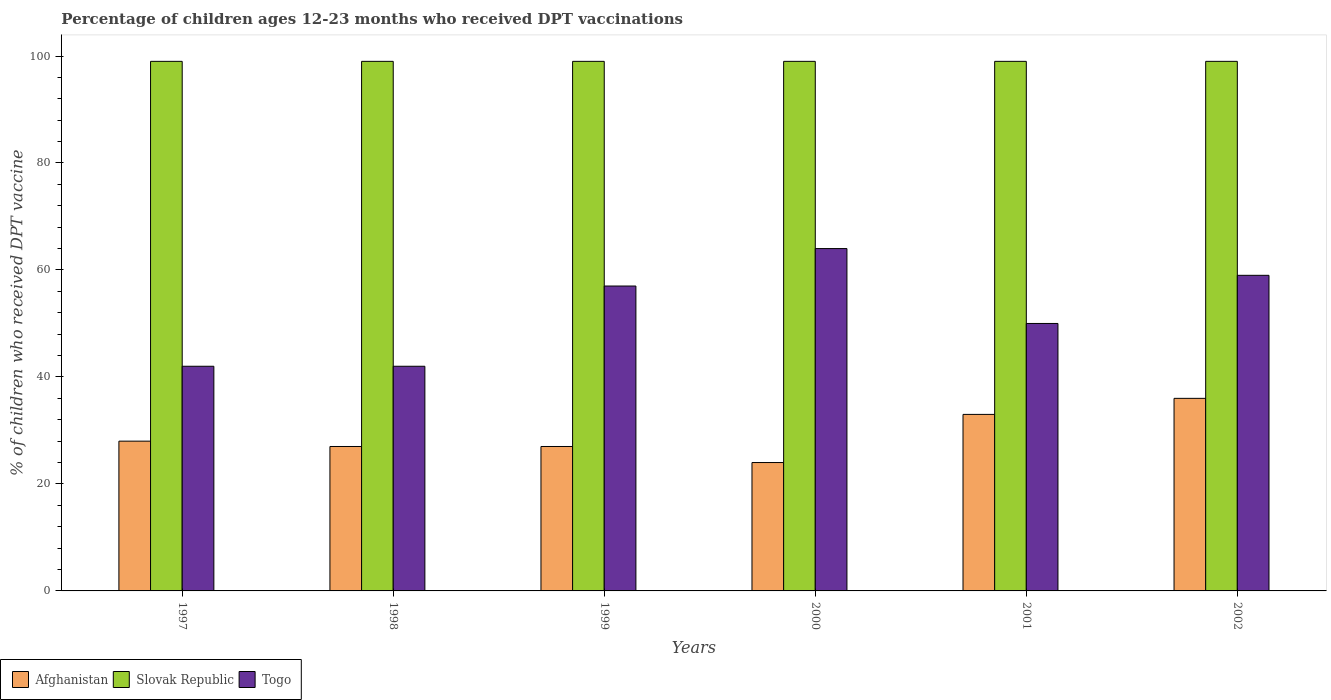How many different coloured bars are there?
Provide a short and direct response. 3. How many groups of bars are there?
Keep it short and to the point. 6. Are the number of bars per tick equal to the number of legend labels?
Your response must be concise. Yes. Are the number of bars on each tick of the X-axis equal?
Make the answer very short. Yes. How many bars are there on the 2nd tick from the left?
Offer a terse response. 3. How many bars are there on the 3rd tick from the right?
Your answer should be compact. 3. In how many cases, is the number of bars for a given year not equal to the number of legend labels?
Provide a succinct answer. 0. What is the percentage of children who received DPT vaccination in Afghanistan in 1998?
Ensure brevity in your answer.  27. Across all years, what is the maximum percentage of children who received DPT vaccination in Afghanistan?
Offer a very short reply. 36. In which year was the percentage of children who received DPT vaccination in Togo minimum?
Offer a terse response. 1997. What is the total percentage of children who received DPT vaccination in Togo in the graph?
Offer a very short reply. 314. What is the difference between the percentage of children who received DPT vaccination in Afghanistan in 1998 and that in 2000?
Make the answer very short. 3. In the year 2000, what is the difference between the percentage of children who received DPT vaccination in Slovak Republic and percentage of children who received DPT vaccination in Afghanistan?
Make the answer very short. 75. In how many years, is the percentage of children who received DPT vaccination in Slovak Republic greater than 76 %?
Offer a terse response. 6. Is the percentage of children who received DPT vaccination in Afghanistan in 1998 less than that in 1999?
Provide a succinct answer. No. Is the difference between the percentage of children who received DPT vaccination in Slovak Republic in 1999 and 2002 greater than the difference between the percentage of children who received DPT vaccination in Afghanistan in 1999 and 2002?
Your response must be concise. Yes. What is the difference between the highest and the second highest percentage of children who received DPT vaccination in Togo?
Offer a terse response. 5. What is the difference between the highest and the lowest percentage of children who received DPT vaccination in Slovak Republic?
Make the answer very short. 0. What does the 1st bar from the left in 2000 represents?
Keep it short and to the point. Afghanistan. What does the 2nd bar from the right in 2001 represents?
Provide a short and direct response. Slovak Republic. How many legend labels are there?
Offer a very short reply. 3. What is the title of the graph?
Ensure brevity in your answer.  Percentage of children ages 12-23 months who received DPT vaccinations. What is the label or title of the X-axis?
Your answer should be compact. Years. What is the label or title of the Y-axis?
Keep it short and to the point. % of children who received DPT vaccine. What is the % of children who received DPT vaccine in Slovak Republic in 1997?
Offer a terse response. 99. What is the % of children who received DPT vaccine in Afghanistan in 1999?
Ensure brevity in your answer.  27. What is the % of children who received DPT vaccine in Slovak Republic in 1999?
Your answer should be compact. 99. What is the % of children who received DPT vaccine of Afghanistan in 2000?
Make the answer very short. 24. What is the % of children who received DPT vaccine in Slovak Republic in 2000?
Your response must be concise. 99. What is the % of children who received DPT vaccine in Togo in 2000?
Make the answer very short. 64. What is the % of children who received DPT vaccine in Slovak Republic in 2001?
Your response must be concise. 99. What is the % of children who received DPT vaccine in Togo in 2001?
Offer a terse response. 50. What is the % of children who received DPT vaccine in Afghanistan in 2002?
Provide a short and direct response. 36. What is the % of children who received DPT vaccine of Togo in 2002?
Keep it short and to the point. 59. Across all years, what is the maximum % of children who received DPT vaccine of Afghanistan?
Ensure brevity in your answer.  36. Across all years, what is the minimum % of children who received DPT vaccine in Slovak Republic?
Give a very brief answer. 99. Across all years, what is the minimum % of children who received DPT vaccine in Togo?
Ensure brevity in your answer.  42. What is the total % of children who received DPT vaccine in Afghanistan in the graph?
Offer a terse response. 175. What is the total % of children who received DPT vaccine in Slovak Republic in the graph?
Your response must be concise. 594. What is the total % of children who received DPT vaccine in Togo in the graph?
Keep it short and to the point. 314. What is the difference between the % of children who received DPT vaccine of Togo in 1997 and that in 1998?
Keep it short and to the point. 0. What is the difference between the % of children who received DPT vaccine in Togo in 1997 and that in 1999?
Ensure brevity in your answer.  -15. What is the difference between the % of children who received DPT vaccine of Togo in 1997 and that in 2001?
Make the answer very short. -8. What is the difference between the % of children who received DPT vaccine of Afghanistan in 1997 and that in 2002?
Make the answer very short. -8. What is the difference between the % of children who received DPT vaccine of Slovak Republic in 1998 and that in 1999?
Your answer should be very brief. 0. What is the difference between the % of children who received DPT vaccine in Afghanistan in 1998 and that in 2000?
Your answer should be very brief. 3. What is the difference between the % of children who received DPT vaccine in Slovak Republic in 1998 and that in 2000?
Make the answer very short. 0. What is the difference between the % of children who received DPT vaccine of Togo in 1998 and that in 2000?
Make the answer very short. -22. What is the difference between the % of children who received DPT vaccine of Afghanistan in 1998 and that in 2001?
Ensure brevity in your answer.  -6. What is the difference between the % of children who received DPT vaccine in Slovak Republic in 1998 and that in 2001?
Your response must be concise. 0. What is the difference between the % of children who received DPT vaccine in Slovak Republic in 1998 and that in 2002?
Keep it short and to the point. 0. What is the difference between the % of children who received DPT vaccine of Afghanistan in 1999 and that in 2000?
Ensure brevity in your answer.  3. What is the difference between the % of children who received DPT vaccine in Slovak Republic in 1999 and that in 2000?
Your answer should be very brief. 0. What is the difference between the % of children who received DPT vaccine of Afghanistan in 1999 and that in 2002?
Your response must be concise. -9. What is the difference between the % of children who received DPT vaccine of Afghanistan in 2000 and that in 2001?
Offer a very short reply. -9. What is the difference between the % of children who received DPT vaccine in Afghanistan in 2000 and that in 2002?
Your answer should be compact. -12. What is the difference between the % of children who received DPT vaccine in Afghanistan in 1997 and the % of children who received DPT vaccine in Slovak Republic in 1998?
Offer a very short reply. -71. What is the difference between the % of children who received DPT vaccine of Afghanistan in 1997 and the % of children who received DPT vaccine of Togo in 1998?
Your answer should be very brief. -14. What is the difference between the % of children who received DPT vaccine in Slovak Republic in 1997 and the % of children who received DPT vaccine in Togo in 1998?
Provide a succinct answer. 57. What is the difference between the % of children who received DPT vaccine of Afghanistan in 1997 and the % of children who received DPT vaccine of Slovak Republic in 1999?
Your answer should be very brief. -71. What is the difference between the % of children who received DPT vaccine in Slovak Republic in 1997 and the % of children who received DPT vaccine in Togo in 1999?
Keep it short and to the point. 42. What is the difference between the % of children who received DPT vaccine in Afghanistan in 1997 and the % of children who received DPT vaccine in Slovak Republic in 2000?
Make the answer very short. -71. What is the difference between the % of children who received DPT vaccine in Afghanistan in 1997 and the % of children who received DPT vaccine in Togo in 2000?
Offer a terse response. -36. What is the difference between the % of children who received DPT vaccine of Afghanistan in 1997 and the % of children who received DPT vaccine of Slovak Republic in 2001?
Keep it short and to the point. -71. What is the difference between the % of children who received DPT vaccine of Afghanistan in 1997 and the % of children who received DPT vaccine of Togo in 2001?
Provide a short and direct response. -22. What is the difference between the % of children who received DPT vaccine in Afghanistan in 1997 and the % of children who received DPT vaccine in Slovak Republic in 2002?
Give a very brief answer. -71. What is the difference between the % of children who received DPT vaccine of Afghanistan in 1997 and the % of children who received DPT vaccine of Togo in 2002?
Give a very brief answer. -31. What is the difference between the % of children who received DPT vaccine of Afghanistan in 1998 and the % of children who received DPT vaccine of Slovak Republic in 1999?
Your answer should be compact. -72. What is the difference between the % of children who received DPT vaccine of Afghanistan in 1998 and the % of children who received DPT vaccine of Slovak Republic in 2000?
Make the answer very short. -72. What is the difference between the % of children who received DPT vaccine of Afghanistan in 1998 and the % of children who received DPT vaccine of Togo in 2000?
Keep it short and to the point. -37. What is the difference between the % of children who received DPT vaccine in Slovak Republic in 1998 and the % of children who received DPT vaccine in Togo in 2000?
Your response must be concise. 35. What is the difference between the % of children who received DPT vaccine of Afghanistan in 1998 and the % of children who received DPT vaccine of Slovak Republic in 2001?
Your answer should be very brief. -72. What is the difference between the % of children who received DPT vaccine in Slovak Republic in 1998 and the % of children who received DPT vaccine in Togo in 2001?
Provide a short and direct response. 49. What is the difference between the % of children who received DPT vaccine of Afghanistan in 1998 and the % of children who received DPT vaccine of Slovak Republic in 2002?
Your response must be concise. -72. What is the difference between the % of children who received DPT vaccine of Afghanistan in 1998 and the % of children who received DPT vaccine of Togo in 2002?
Keep it short and to the point. -32. What is the difference between the % of children who received DPT vaccine of Afghanistan in 1999 and the % of children who received DPT vaccine of Slovak Republic in 2000?
Keep it short and to the point. -72. What is the difference between the % of children who received DPT vaccine in Afghanistan in 1999 and the % of children who received DPT vaccine in Togo in 2000?
Your response must be concise. -37. What is the difference between the % of children who received DPT vaccine in Afghanistan in 1999 and the % of children who received DPT vaccine in Slovak Republic in 2001?
Provide a short and direct response. -72. What is the difference between the % of children who received DPT vaccine in Slovak Republic in 1999 and the % of children who received DPT vaccine in Togo in 2001?
Ensure brevity in your answer.  49. What is the difference between the % of children who received DPT vaccine of Afghanistan in 1999 and the % of children who received DPT vaccine of Slovak Republic in 2002?
Keep it short and to the point. -72. What is the difference between the % of children who received DPT vaccine of Afghanistan in 1999 and the % of children who received DPT vaccine of Togo in 2002?
Give a very brief answer. -32. What is the difference between the % of children who received DPT vaccine in Slovak Republic in 1999 and the % of children who received DPT vaccine in Togo in 2002?
Offer a very short reply. 40. What is the difference between the % of children who received DPT vaccine of Afghanistan in 2000 and the % of children who received DPT vaccine of Slovak Republic in 2001?
Provide a succinct answer. -75. What is the difference between the % of children who received DPT vaccine in Afghanistan in 2000 and the % of children who received DPT vaccine in Slovak Republic in 2002?
Ensure brevity in your answer.  -75. What is the difference between the % of children who received DPT vaccine of Afghanistan in 2000 and the % of children who received DPT vaccine of Togo in 2002?
Give a very brief answer. -35. What is the difference between the % of children who received DPT vaccine in Slovak Republic in 2000 and the % of children who received DPT vaccine in Togo in 2002?
Give a very brief answer. 40. What is the difference between the % of children who received DPT vaccine of Afghanistan in 2001 and the % of children who received DPT vaccine of Slovak Republic in 2002?
Your answer should be compact. -66. What is the average % of children who received DPT vaccine in Afghanistan per year?
Make the answer very short. 29.17. What is the average % of children who received DPT vaccine in Slovak Republic per year?
Make the answer very short. 99. What is the average % of children who received DPT vaccine in Togo per year?
Give a very brief answer. 52.33. In the year 1997, what is the difference between the % of children who received DPT vaccine of Afghanistan and % of children who received DPT vaccine of Slovak Republic?
Your answer should be compact. -71. In the year 1998, what is the difference between the % of children who received DPT vaccine of Afghanistan and % of children who received DPT vaccine of Slovak Republic?
Ensure brevity in your answer.  -72. In the year 1998, what is the difference between the % of children who received DPT vaccine of Afghanistan and % of children who received DPT vaccine of Togo?
Provide a succinct answer. -15. In the year 1999, what is the difference between the % of children who received DPT vaccine of Afghanistan and % of children who received DPT vaccine of Slovak Republic?
Provide a short and direct response. -72. In the year 1999, what is the difference between the % of children who received DPT vaccine of Afghanistan and % of children who received DPT vaccine of Togo?
Make the answer very short. -30. In the year 1999, what is the difference between the % of children who received DPT vaccine of Slovak Republic and % of children who received DPT vaccine of Togo?
Make the answer very short. 42. In the year 2000, what is the difference between the % of children who received DPT vaccine of Afghanistan and % of children who received DPT vaccine of Slovak Republic?
Provide a short and direct response. -75. In the year 2000, what is the difference between the % of children who received DPT vaccine in Slovak Republic and % of children who received DPT vaccine in Togo?
Your response must be concise. 35. In the year 2001, what is the difference between the % of children who received DPT vaccine in Afghanistan and % of children who received DPT vaccine in Slovak Republic?
Keep it short and to the point. -66. In the year 2002, what is the difference between the % of children who received DPT vaccine in Afghanistan and % of children who received DPT vaccine in Slovak Republic?
Provide a short and direct response. -63. In the year 2002, what is the difference between the % of children who received DPT vaccine of Afghanistan and % of children who received DPT vaccine of Togo?
Provide a short and direct response. -23. What is the ratio of the % of children who received DPT vaccine of Togo in 1997 to that in 1999?
Your response must be concise. 0.74. What is the ratio of the % of children who received DPT vaccine in Afghanistan in 1997 to that in 2000?
Offer a terse response. 1.17. What is the ratio of the % of children who received DPT vaccine of Togo in 1997 to that in 2000?
Give a very brief answer. 0.66. What is the ratio of the % of children who received DPT vaccine in Afghanistan in 1997 to that in 2001?
Offer a very short reply. 0.85. What is the ratio of the % of children who received DPT vaccine of Slovak Republic in 1997 to that in 2001?
Provide a succinct answer. 1. What is the ratio of the % of children who received DPT vaccine of Togo in 1997 to that in 2001?
Provide a short and direct response. 0.84. What is the ratio of the % of children who received DPT vaccine of Afghanistan in 1997 to that in 2002?
Make the answer very short. 0.78. What is the ratio of the % of children who received DPT vaccine in Togo in 1997 to that in 2002?
Offer a terse response. 0.71. What is the ratio of the % of children who received DPT vaccine in Afghanistan in 1998 to that in 1999?
Offer a terse response. 1. What is the ratio of the % of children who received DPT vaccine in Togo in 1998 to that in 1999?
Provide a succinct answer. 0.74. What is the ratio of the % of children who received DPT vaccine of Afghanistan in 1998 to that in 2000?
Offer a very short reply. 1.12. What is the ratio of the % of children who received DPT vaccine in Togo in 1998 to that in 2000?
Offer a very short reply. 0.66. What is the ratio of the % of children who received DPT vaccine of Afghanistan in 1998 to that in 2001?
Make the answer very short. 0.82. What is the ratio of the % of children who received DPT vaccine of Slovak Republic in 1998 to that in 2001?
Your answer should be very brief. 1. What is the ratio of the % of children who received DPT vaccine of Togo in 1998 to that in 2001?
Your answer should be very brief. 0.84. What is the ratio of the % of children who received DPT vaccine in Slovak Republic in 1998 to that in 2002?
Offer a very short reply. 1. What is the ratio of the % of children who received DPT vaccine of Togo in 1998 to that in 2002?
Provide a succinct answer. 0.71. What is the ratio of the % of children who received DPT vaccine in Togo in 1999 to that in 2000?
Make the answer very short. 0.89. What is the ratio of the % of children who received DPT vaccine in Afghanistan in 1999 to that in 2001?
Give a very brief answer. 0.82. What is the ratio of the % of children who received DPT vaccine in Togo in 1999 to that in 2001?
Offer a very short reply. 1.14. What is the ratio of the % of children who received DPT vaccine of Afghanistan in 1999 to that in 2002?
Provide a succinct answer. 0.75. What is the ratio of the % of children who received DPT vaccine in Slovak Republic in 1999 to that in 2002?
Your answer should be very brief. 1. What is the ratio of the % of children who received DPT vaccine of Togo in 1999 to that in 2002?
Provide a succinct answer. 0.97. What is the ratio of the % of children who received DPT vaccine of Afghanistan in 2000 to that in 2001?
Make the answer very short. 0.73. What is the ratio of the % of children who received DPT vaccine in Slovak Republic in 2000 to that in 2001?
Provide a short and direct response. 1. What is the ratio of the % of children who received DPT vaccine in Togo in 2000 to that in 2001?
Offer a very short reply. 1.28. What is the ratio of the % of children who received DPT vaccine of Togo in 2000 to that in 2002?
Keep it short and to the point. 1.08. What is the ratio of the % of children who received DPT vaccine in Afghanistan in 2001 to that in 2002?
Your answer should be very brief. 0.92. What is the ratio of the % of children who received DPT vaccine of Togo in 2001 to that in 2002?
Make the answer very short. 0.85. What is the difference between the highest and the second highest % of children who received DPT vaccine in Afghanistan?
Give a very brief answer. 3. What is the difference between the highest and the second highest % of children who received DPT vaccine in Togo?
Keep it short and to the point. 5. What is the difference between the highest and the lowest % of children who received DPT vaccine of Slovak Republic?
Your response must be concise. 0. 